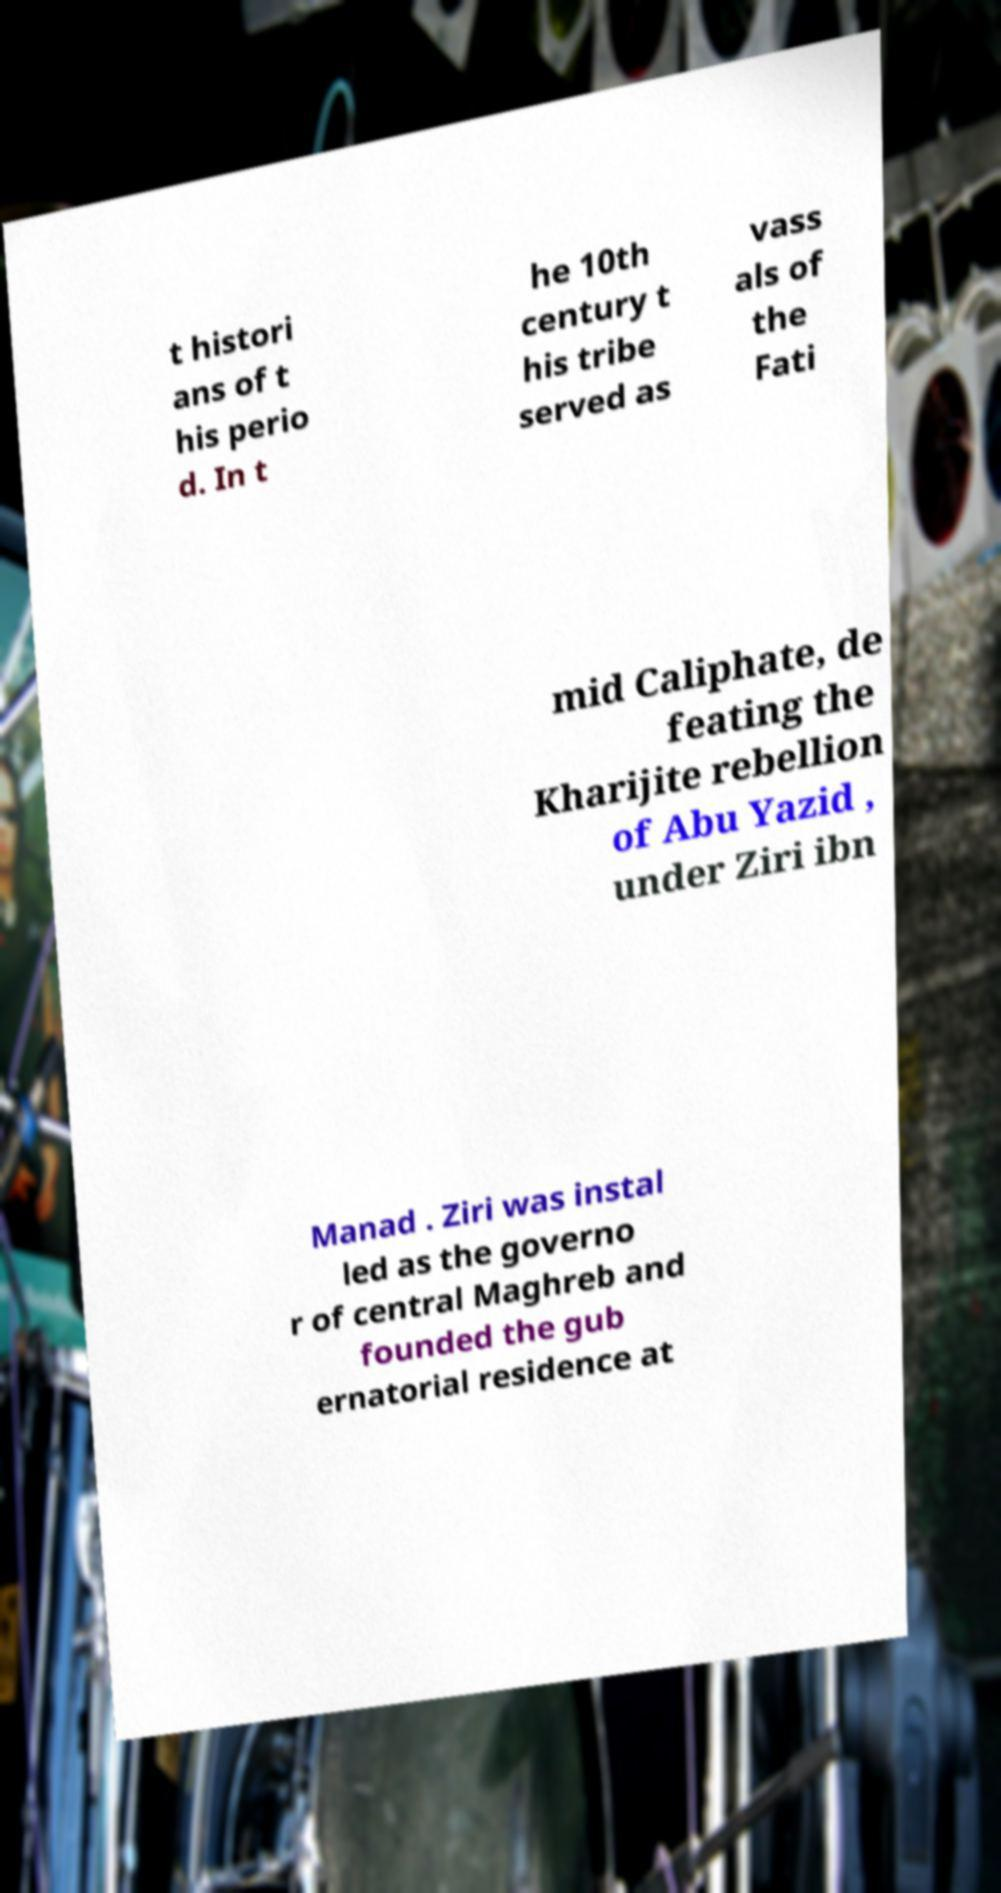What messages or text are displayed in this image? I need them in a readable, typed format. t histori ans of t his perio d. In t he 10th century t his tribe served as vass als of the Fati mid Caliphate, de feating the Kharijite rebellion of Abu Yazid , under Ziri ibn Manad . Ziri was instal led as the governo r of central Maghreb and founded the gub ernatorial residence at 